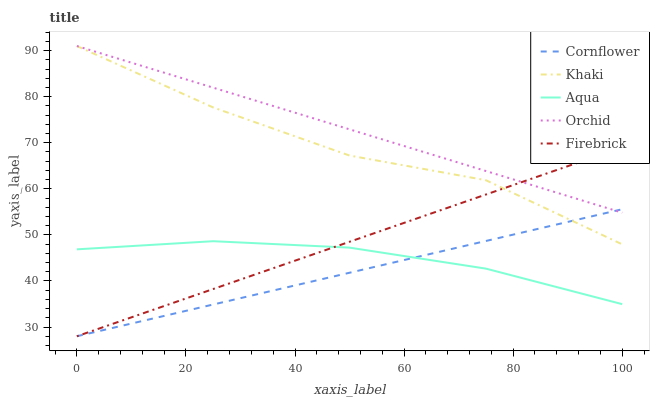Does Cornflower have the minimum area under the curve?
Answer yes or no. Yes. Does Orchid have the maximum area under the curve?
Answer yes or no. Yes. Does Firebrick have the minimum area under the curve?
Answer yes or no. No. Does Firebrick have the maximum area under the curve?
Answer yes or no. No. Is Cornflower the smoothest?
Answer yes or no. Yes. Is Khaki the roughest?
Answer yes or no. Yes. Is Khaki the smoothest?
Answer yes or no. No. Is Firebrick the roughest?
Answer yes or no. No. Does Cornflower have the lowest value?
Answer yes or no. Yes. Does Khaki have the lowest value?
Answer yes or no. No. Does Orchid have the highest value?
Answer yes or no. Yes. Does Firebrick have the highest value?
Answer yes or no. No. Is Aqua less than Orchid?
Answer yes or no. Yes. Is Orchid greater than Aqua?
Answer yes or no. Yes. Does Khaki intersect Cornflower?
Answer yes or no. Yes. Is Khaki less than Cornflower?
Answer yes or no. No. Is Khaki greater than Cornflower?
Answer yes or no. No. Does Aqua intersect Orchid?
Answer yes or no. No. 